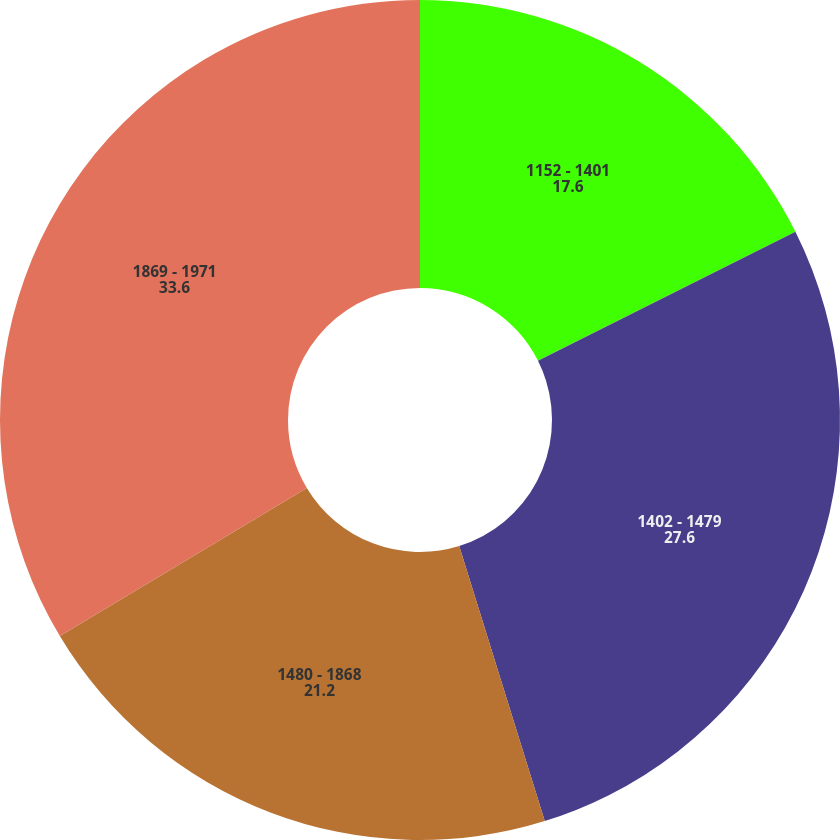Convert chart. <chart><loc_0><loc_0><loc_500><loc_500><pie_chart><fcel>1152 - 1401<fcel>1402 - 1479<fcel>1480 - 1868<fcel>1869 - 1971<nl><fcel>17.6%<fcel>27.6%<fcel>21.2%<fcel>33.6%<nl></chart> 